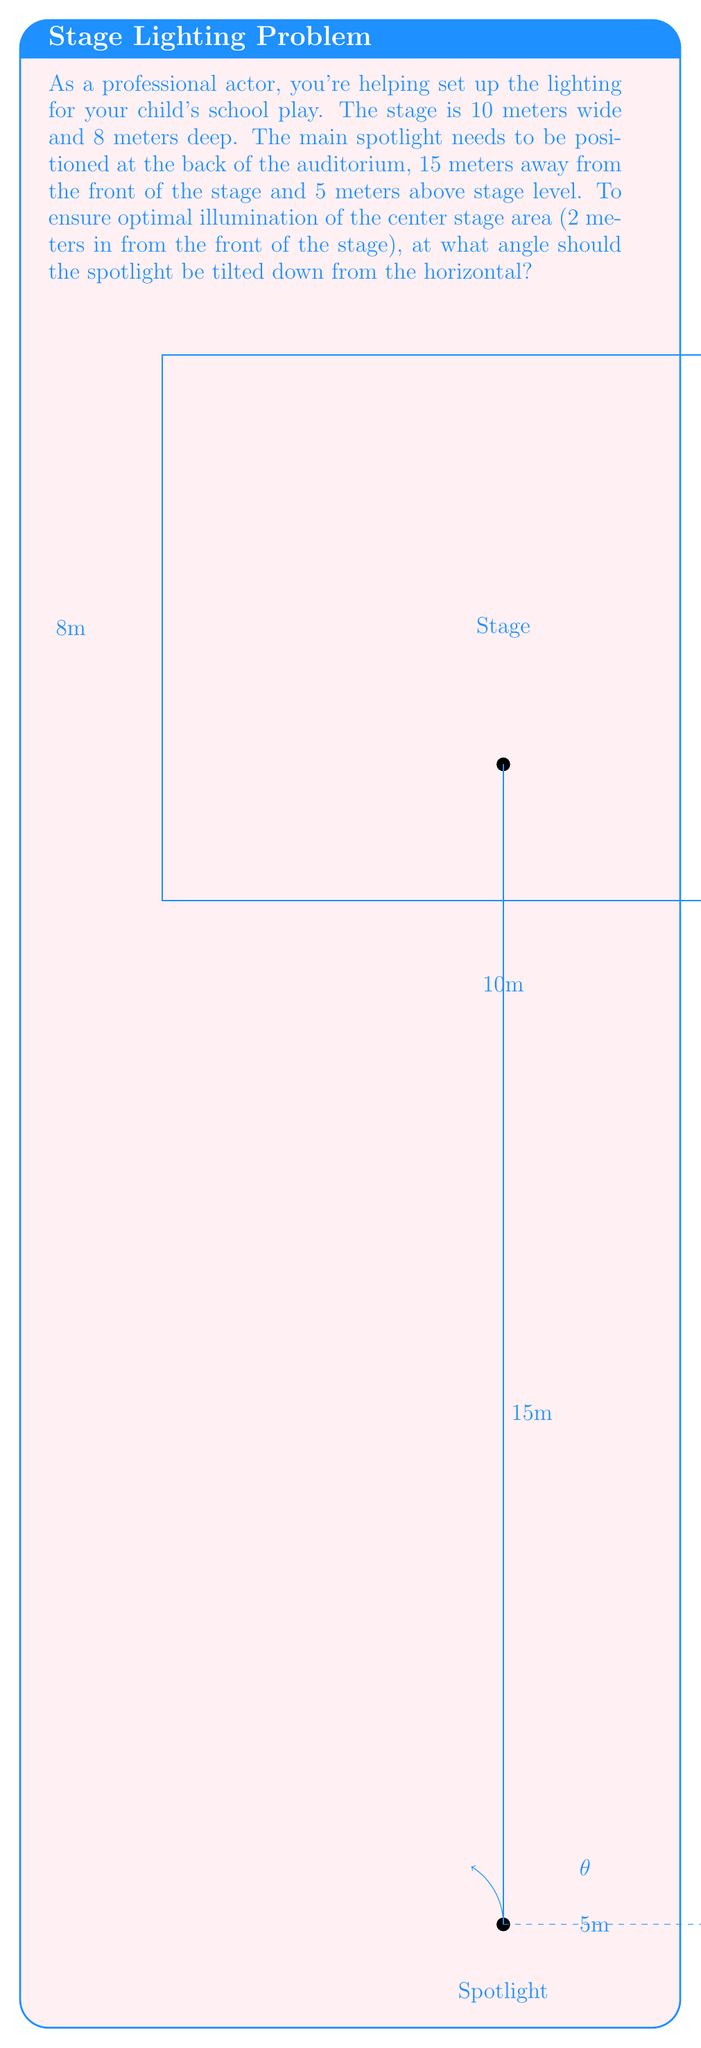Can you solve this math problem? To solve this problem, we'll use trigonometry. Let's break it down step-by-step:

1) First, let's identify the right triangle formed by the spotlight beam:
   - The vertical distance from the spotlight to stage level is 5 meters.
   - The horizontal distance from the spotlight to the front of the stage is 15 meters.
   - The distance from the front of the stage to the center stage area is 2 meters.

2) The total horizontal distance from the spotlight to the center stage point is:
   $15 + 2 = 17$ meters

3) The total vertical distance from the spotlight to the stage floor is 5 meters.

4) Now we have a right triangle where:
   - The adjacent side (horizontal distance) is 17 meters
   - The opposite side (vertical distance) is 5 meters

5) To find the angle, we use the tangent function:

   $$\tan(\theta) = \frac{\text{opposite}}{\text{adjacent}} = \frac{5}{17}$$

6) To solve for $\theta$, we take the inverse tangent (arctangent):

   $$\theta = \arctan(\frac{5}{17})$$

7) Using a calculator or computer:

   $$\theta \approx 16.39°$$

This angle is measured from the horizontal, which is exactly what we need for tilting the spotlight downward.
Answer: $16.39°$ 